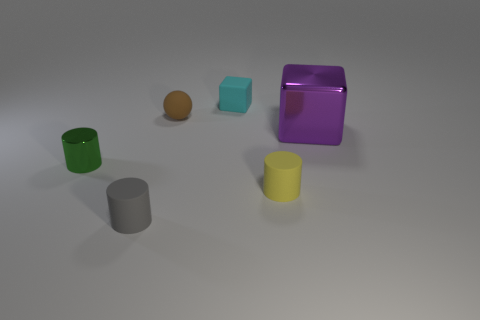Is there anything else that has the same shape as the brown matte thing?
Make the answer very short. No. The block in front of the tiny sphere is what color?
Your response must be concise. Purple. Is the size of the shiny object to the left of the small gray thing the same as the rubber cylinder that is behind the small gray matte object?
Offer a very short reply. Yes. How many objects are small cyan rubber things or small gray objects?
Give a very brief answer. 2. What is the material of the object left of the small matte cylinder that is on the left side of the small block?
Offer a terse response. Metal. What number of yellow rubber things are the same shape as the gray object?
Your response must be concise. 1. Are there any rubber things of the same color as the tiny rubber ball?
Ensure brevity in your answer.  No. What number of things are either cylinders to the right of the tiny green metallic cylinder or tiny cylinders in front of the tiny green object?
Provide a short and direct response. 2. Is there a small thing right of the shiny thing in front of the large purple metal thing?
Give a very brief answer. Yes. There is a cyan rubber thing that is the same size as the sphere; what shape is it?
Provide a short and direct response. Cube. 